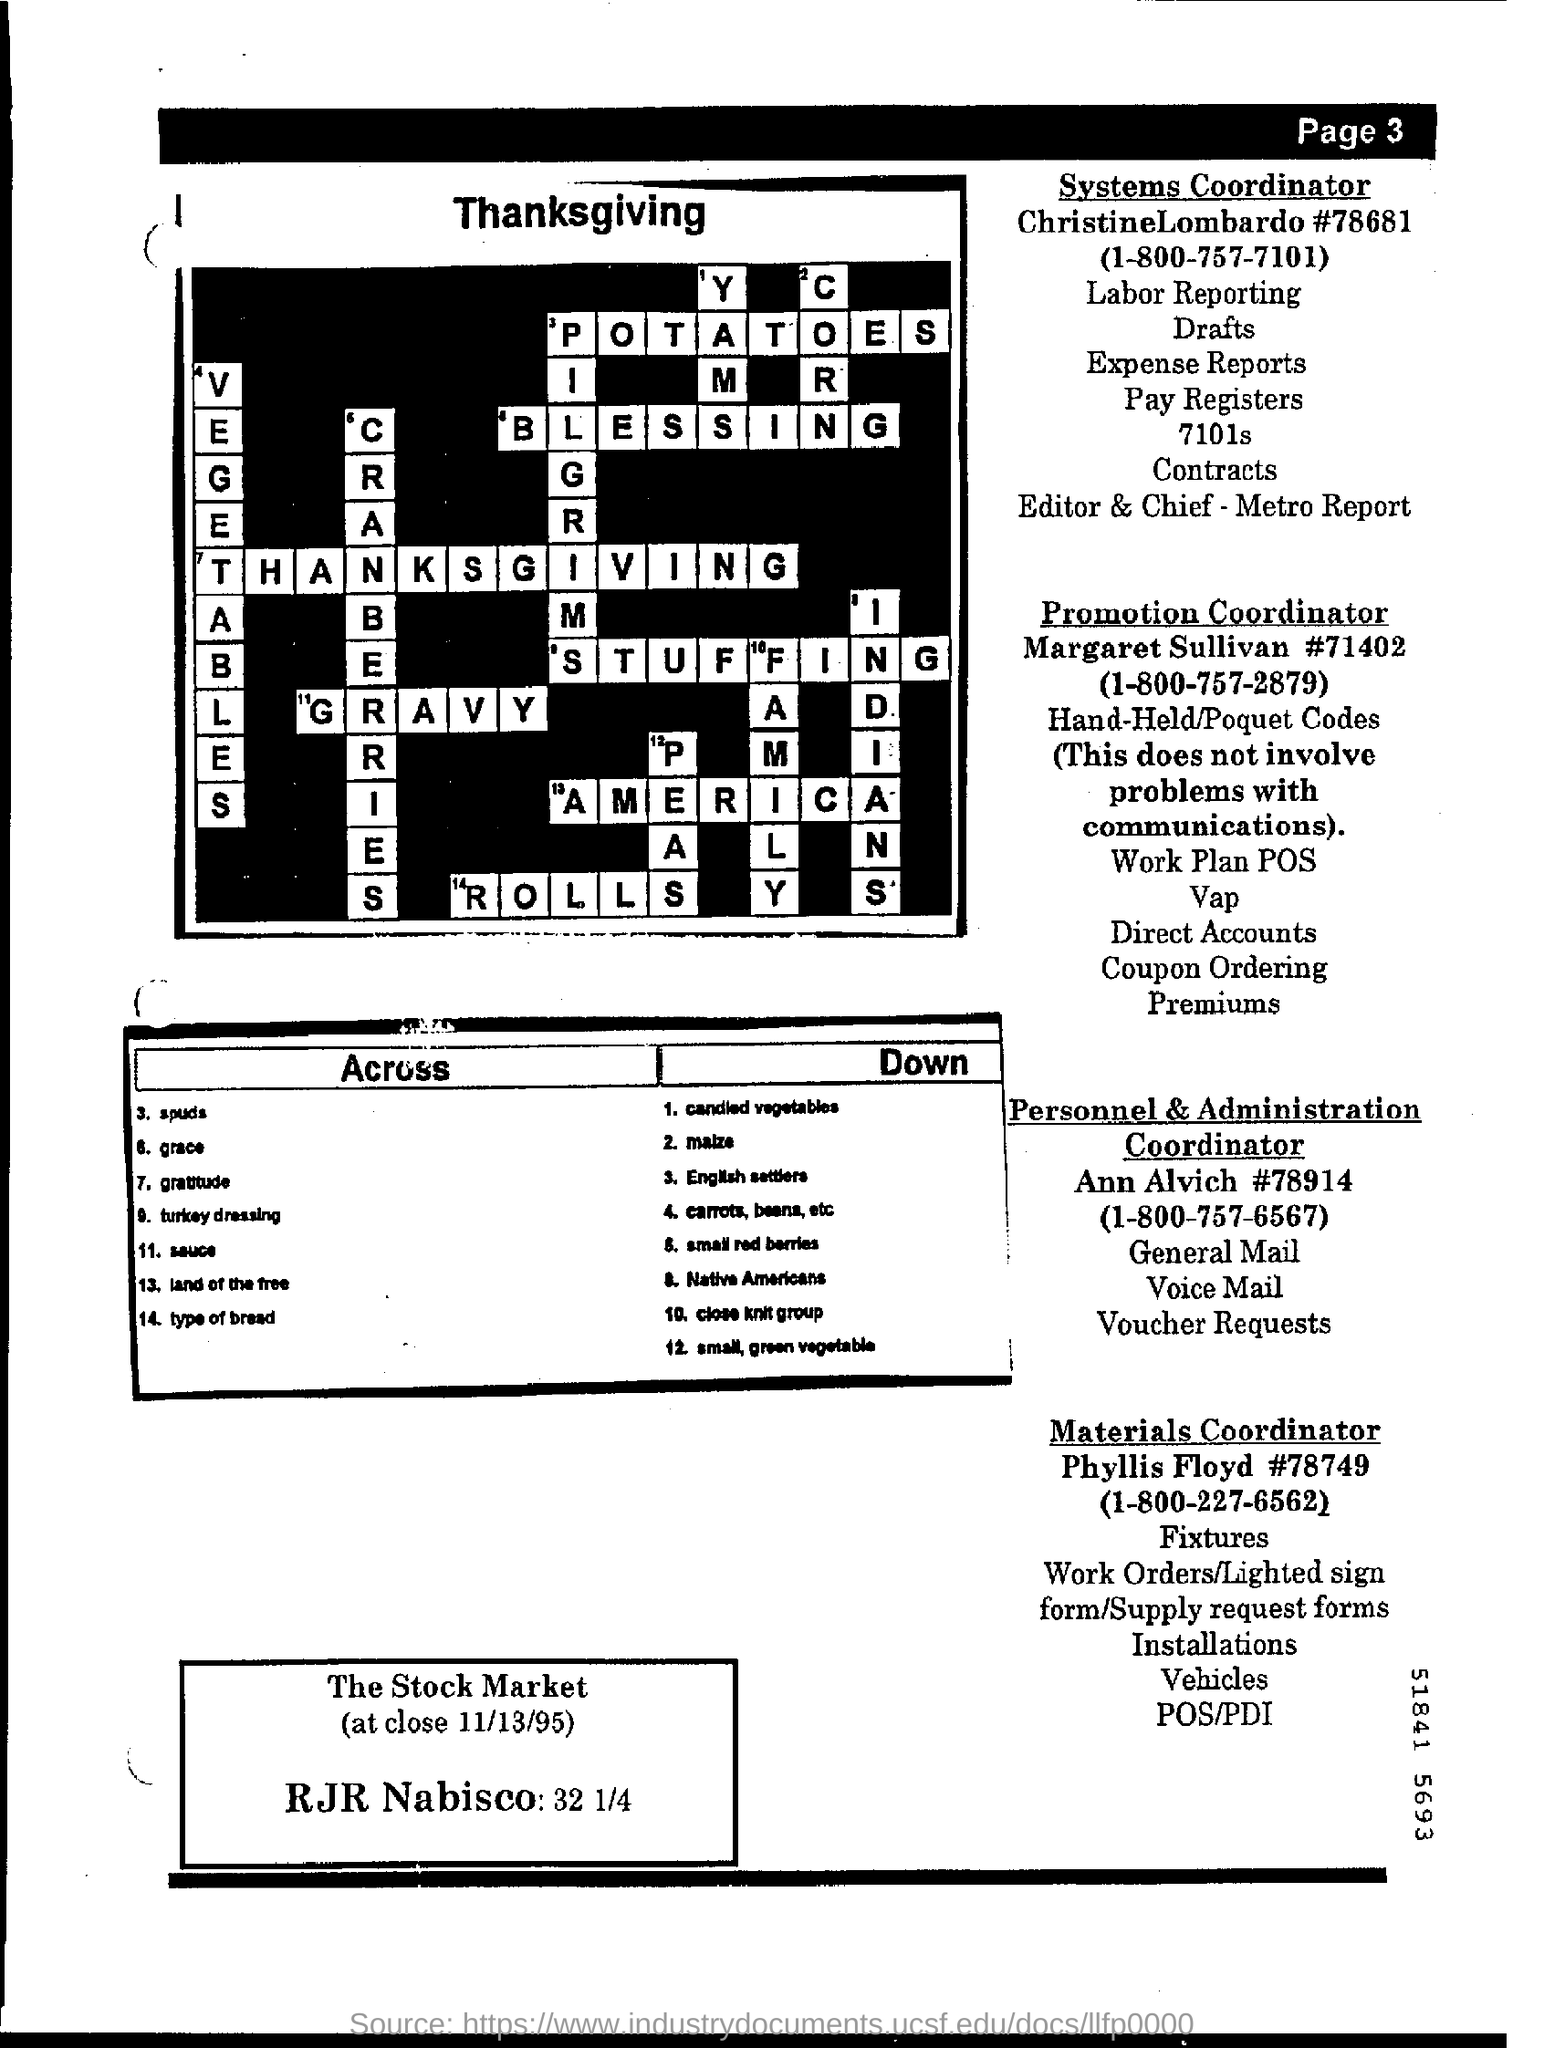Outline some significant characteristics in this image. The Systems Coordinator is Christine Lombardo. Margaret Sullivan is the Promotion Coordinator. 